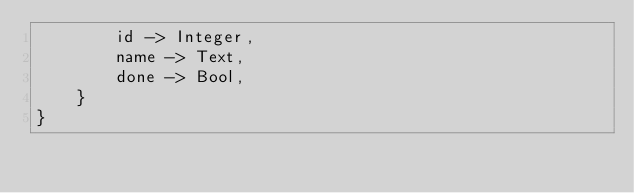Convert code to text. <code><loc_0><loc_0><loc_500><loc_500><_Rust_>        id -> Integer,
        name -> Text,
        done -> Bool,
    }
}
</code> 